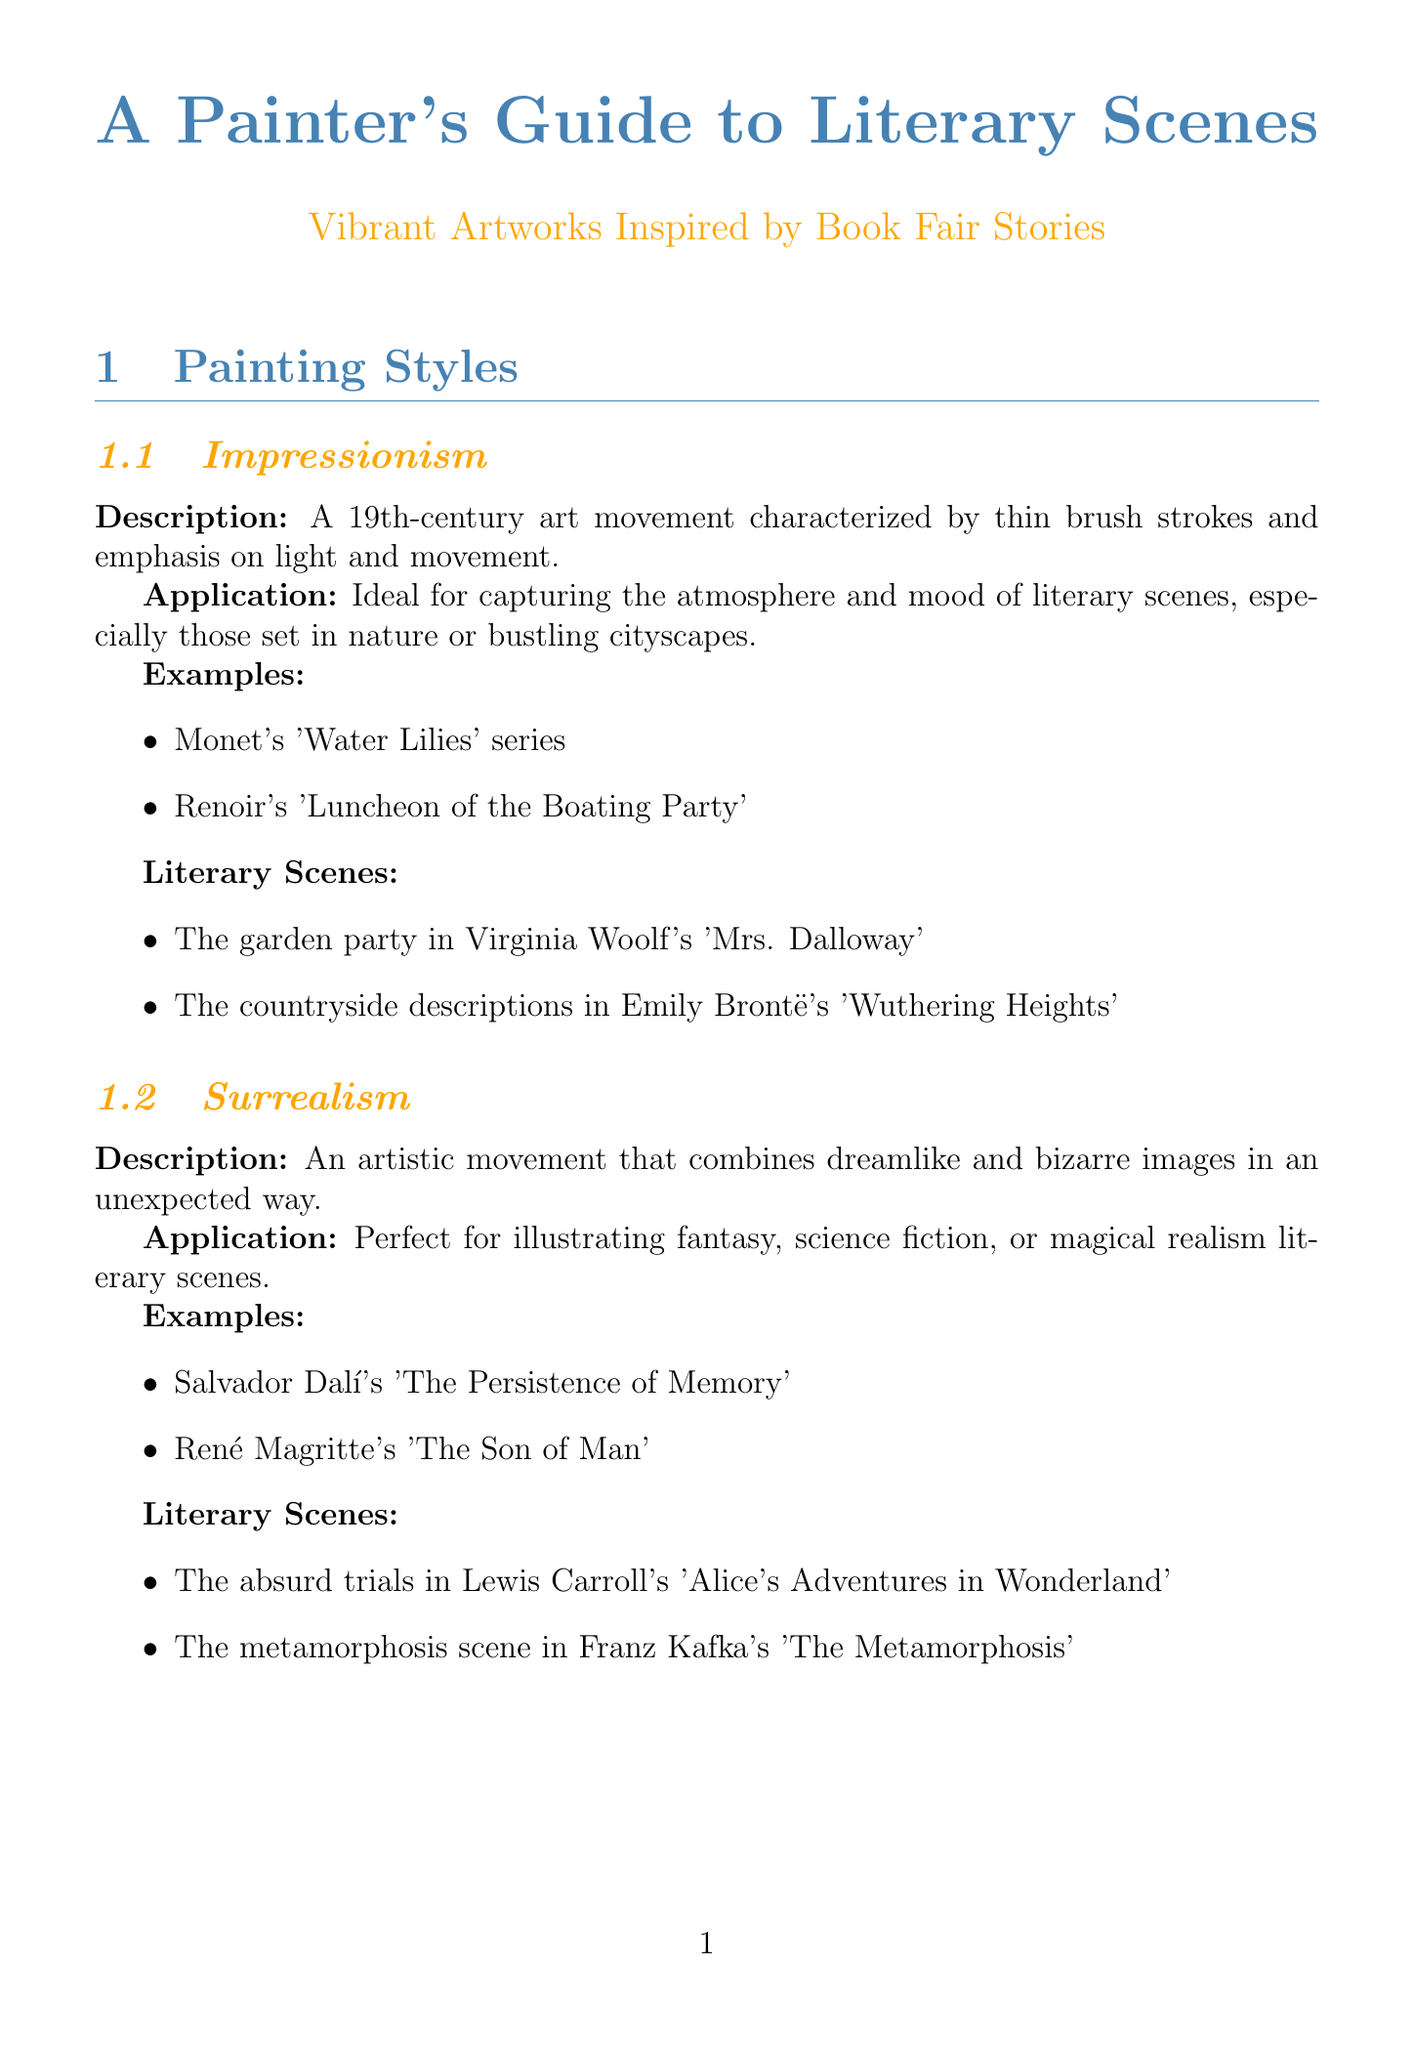What are the three painting styles mentioned? The document identifies Impressionism, Surrealism, and Expressionism as the three painting styles.
Answer: Impressionism, Surrealism, Expressionism Which painting technique is characterized by strong contrasts between light and dark? The technique that uses strong contrasts between light and dark is called Chiaroscuro.
Answer: Chiaroscuro What color theory principle involves using opposite colors on the color wheel? The principle that involves using colors opposite each other on the color wheel is called Complementary Colors.
Answer: Complementary Colors Name a literary scene that can be depicted using Impressionism. One literary scene that can be depicted using Impressionism is the garden party in Virginia Woolf's 'Mrs. Dalloway'.
Answer: The garden party in Virginia Woolf's 'Mrs. Dalloway' Which element of composition is described as dividing the canvas into a 3x3 grid? The composition element described as dividing the canvas into a 3x3 grid is called the Rule of Thirds.
Answer: Rule of Thirds What is the application of the Sfumato technique? Sfumato is ideal for depicting dream sequences or memories in literary scenes.
Answer: Depicting dream sequences or memories Which artist painted 'The Scream'? The artist who painted 'The Scream' is Edvard Munch.
Answer: Edvard Munch How many examples are provided for Expressionism? The document provides two examples for Expressionism.
Answer: Two 